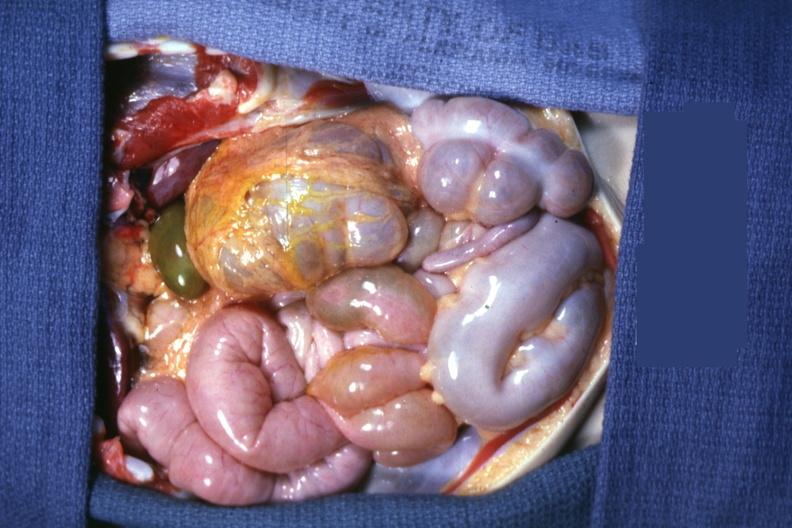does omphalocele show opened peritoneal cavity showing cecum and appendix on left side?
Answer the question using a single word or phrase. No 